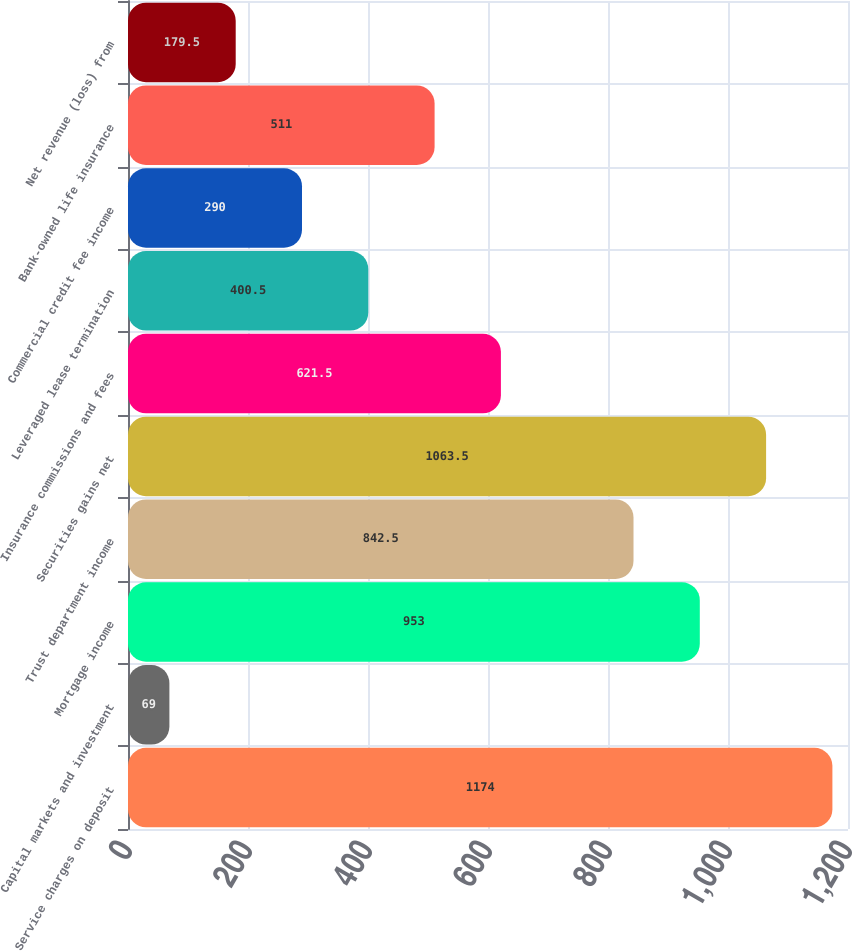Convert chart. <chart><loc_0><loc_0><loc_500><loc_500><bar_chart><fcel>Service charges on deposit<fcel>Capital markets and investment<fcel>Mortgage income<fcel>Trust department income<fcel>Securities gains net<fcel>Insurance commissions and fees<fcel>Leveraged lease termination<fcel>Commercial credit fee income<fcel>Bank-owned life insurance<fcel>Net revenue (loss) from<nl><fcel>1174<fcel>69<fcel>953<fcel>842.5<fcel>1063.5<fcel>621.5<fcel>400.5<fcel>290<fcel>511<fcel>179.5<nl></chart> 